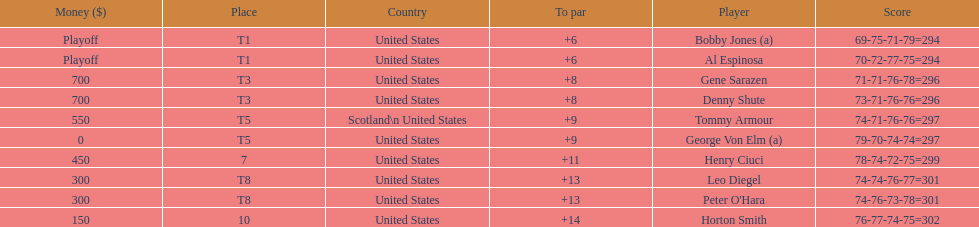Gene sarazen and denny shute are both from which country? United States. 